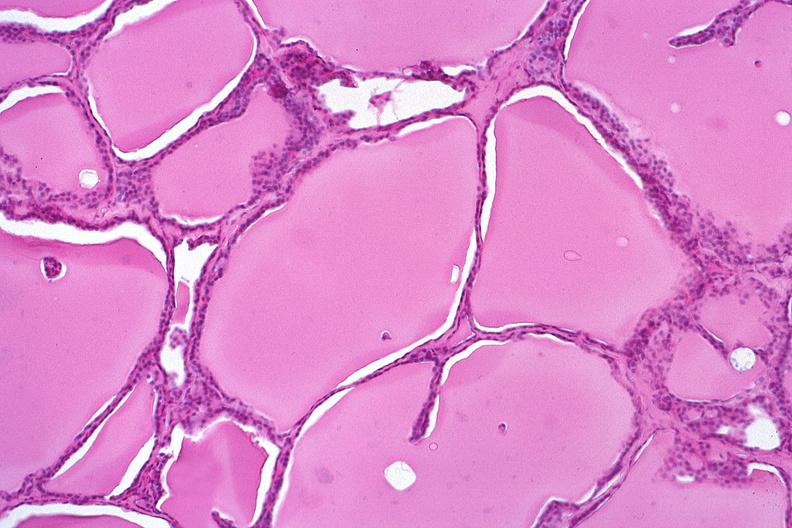s lesion present?
Answer the question using a single word or phrase. No 